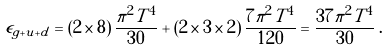<formula> <loc_0><loc_0><loc_500><loc_500>\epsilon _ { g + u + d } = ( 2 \times 8 ) \, \frac { \pi ^ { 2 } T ^ { 4 } } { 3 0 } + ( 2 \times 3 \times 2 ) \, \frac { 7 \pi ^ { 2 } T ^ { 4 } } { 1 2 0 } = \frac { 3 7 \pi ^ { 2 } T ^ { 4 } } { 3 0 } \, .</formula> 